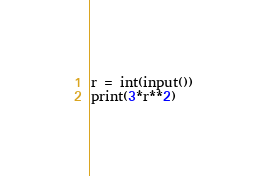<code> <loc_0><loc_0><loc_500><loc_500><_Python_>r = int(input())
print(3*r**2)</code> 